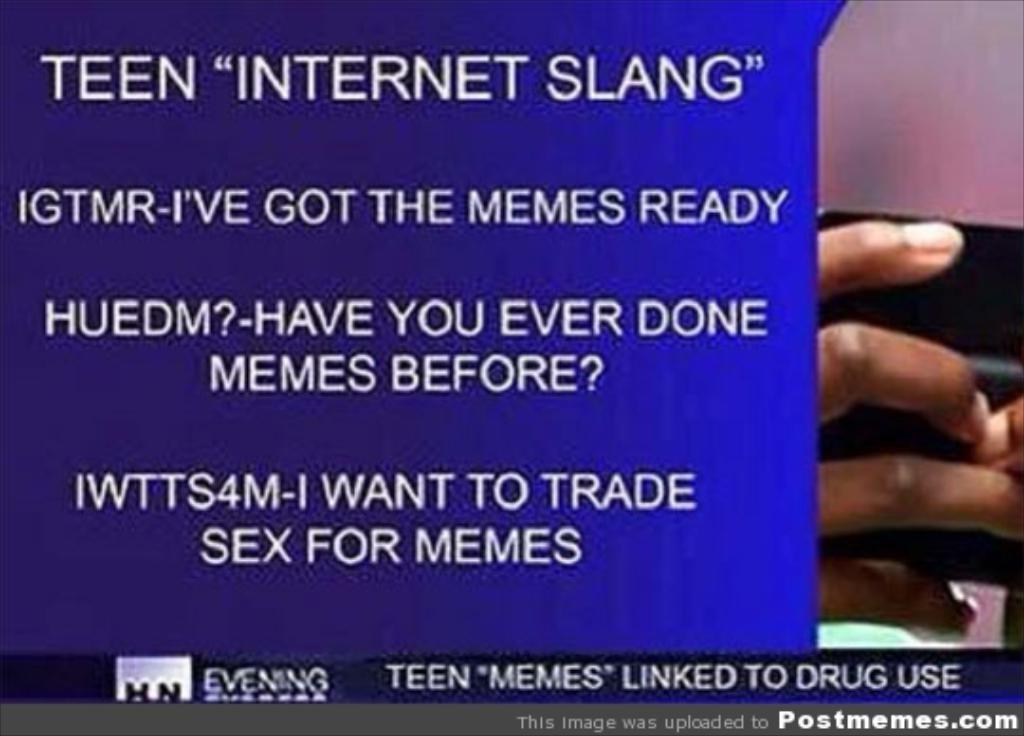What is featured on the poster in the image? There is a poster with text in the image. Can you describe the fingers holding an object in the image? The fingers of a person are holding an object on the right side of the image. What type of eggnog is being blown by the person in the image? There is no eggnog or blowing action present in the image. What is the floor made of in the image? The image does not show the floor, so it cannot be determined what material it might be made of. 